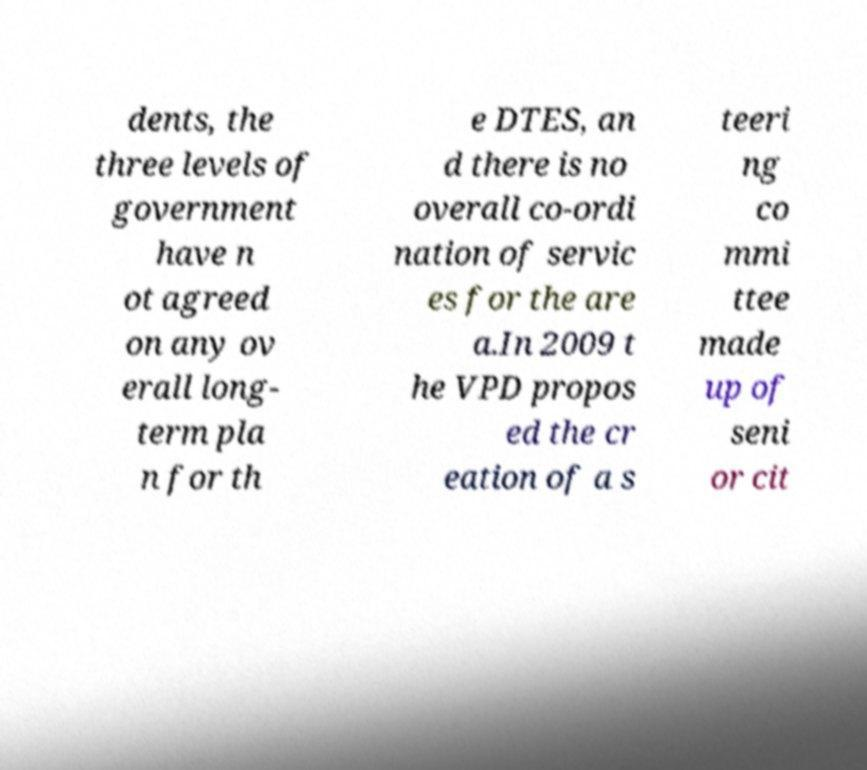Please read and relay the text visible in this image. What does it say? dents, the three levels of government have n ot agreed on any ov erall long- term pla n for th e DTES, an d there is no overall co-ordi nation of servic es for the are a.In 2009 t he VPD propos ed the cr eation of a s teeri ng co mmi ttee made up of seni or cit 